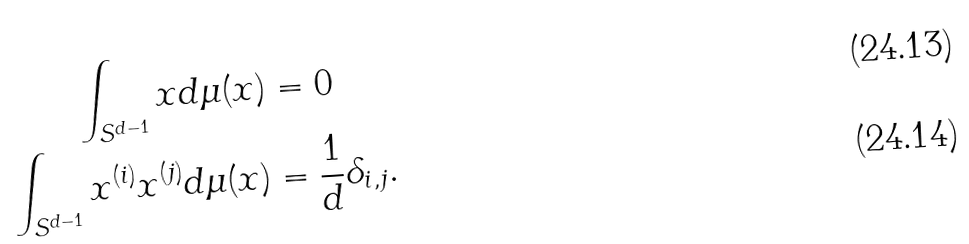<formula> <loc_0><loc_0><loc_500><loc_500>\int _ { S ^ { d - 1 } } x d \mu ( x ) & = 0 \\ \int _ { S ^ { d - 1 } } x ^ { ( i ) } x ^ { ( j ) } d \mu ( x ) & = \frac { 1 } { d } \delta _ { i , j } .</formula> 